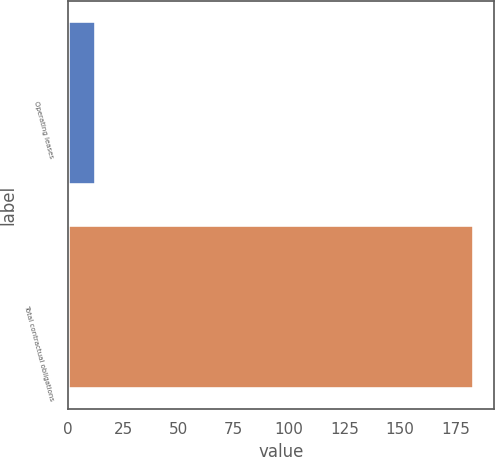Convert chart. <chart><loc_0><loc_0><loc_500><loc_500><bar_chart><fcel>Operating leases<fcel>Total contractual obligations<nl><fcel>12.7<fcel>183.4<nl></chart> 